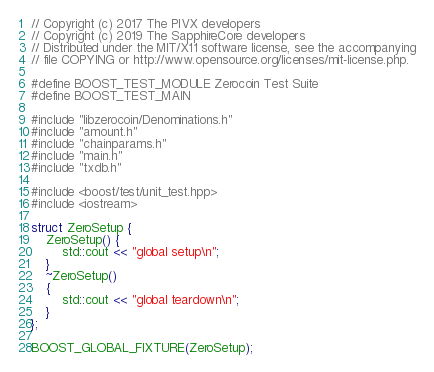Convert code to text. <code><loc_0><loc_0><loc_500><loc_500><_C++_>// Copyright (c) 2017 The PIVX developers
// Copyright (c) 2019 The SapphireCore developers
// Distributed under the MIT/X11 software license, see the accompanying
// file COPYING or http://www.opensource.org/licenses/mit-license.php.

#define BOOST_TEST_MODULE Zerocoin Test Suite
#define BOOST_TEST_MAIN

#include "libzerocoin/Denominations.h"
#include "amount.h"
#include "chainparams.h"
#include "main.h"
#include "txdb.h"

#include <boost/test/unit_test.hpp>
#include <iostream>

struct ZeroSetup {
    ZeroSetup() {
        std::cout << "global setup\n";
    }
    ~ZeroSetup()
    {
        std::cout << "global teardown\n";
    }
};

BOOST_GLOBAL_FIXTURE(ZeroSetup);

</code> 